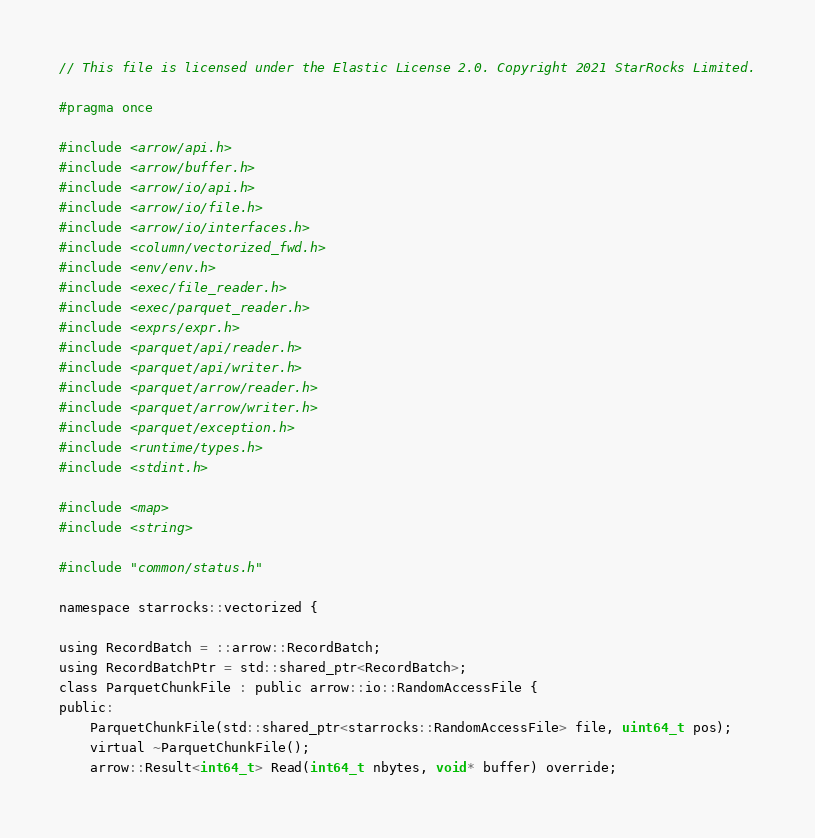Convert code to text. <code><loc_0><loc_0><loc_500><loc_500><_C_>// This file is licensed under the Elastic License 2.0. Copyright 2021 StarRocks Limited.

#pragma once

#include <arrow/api.h>
#include <arrow/buffer.h>
#include <arrow/io/api.h>
#include <arrow/io/file.h>
#include <arrow/io/interfaces.h>
#include <column/vectorized_fwd.h>
#include <env/env.h>
#include <exec/file_reader.h>
#include <exec/parquet_reader.h>
#include <exprs/expr.h>
#include <parquet/api/reader.h>
#include <parquet/api/writer.h>
#include <parquet/arrow/reader.h>
#include <parquet/arrow/writer.h>
#include <parquet/exception.h>
#include <runtime/types.h>
#include <stdint.h>

#include <map>
#include <string>

#include "common/status.h"

namespace starrocks::vectorized {

using RecordBatch = ::arrow::RecordBatch;
using RecordBatchPtr = std::shared_ptr<RecordBatch>;
class ParquetChunkFile : public arrow::io::RandomAccessFile {
public:
    ParquetChunkFile(std::shared_ptr<starrocks::RandomAccessFile> file, uint64_t pos);
    virtual ~ParquetChunkFile();
    arrow::Result<int64_t> Read(int64_t nbytes, void* buffer) override;</code> 